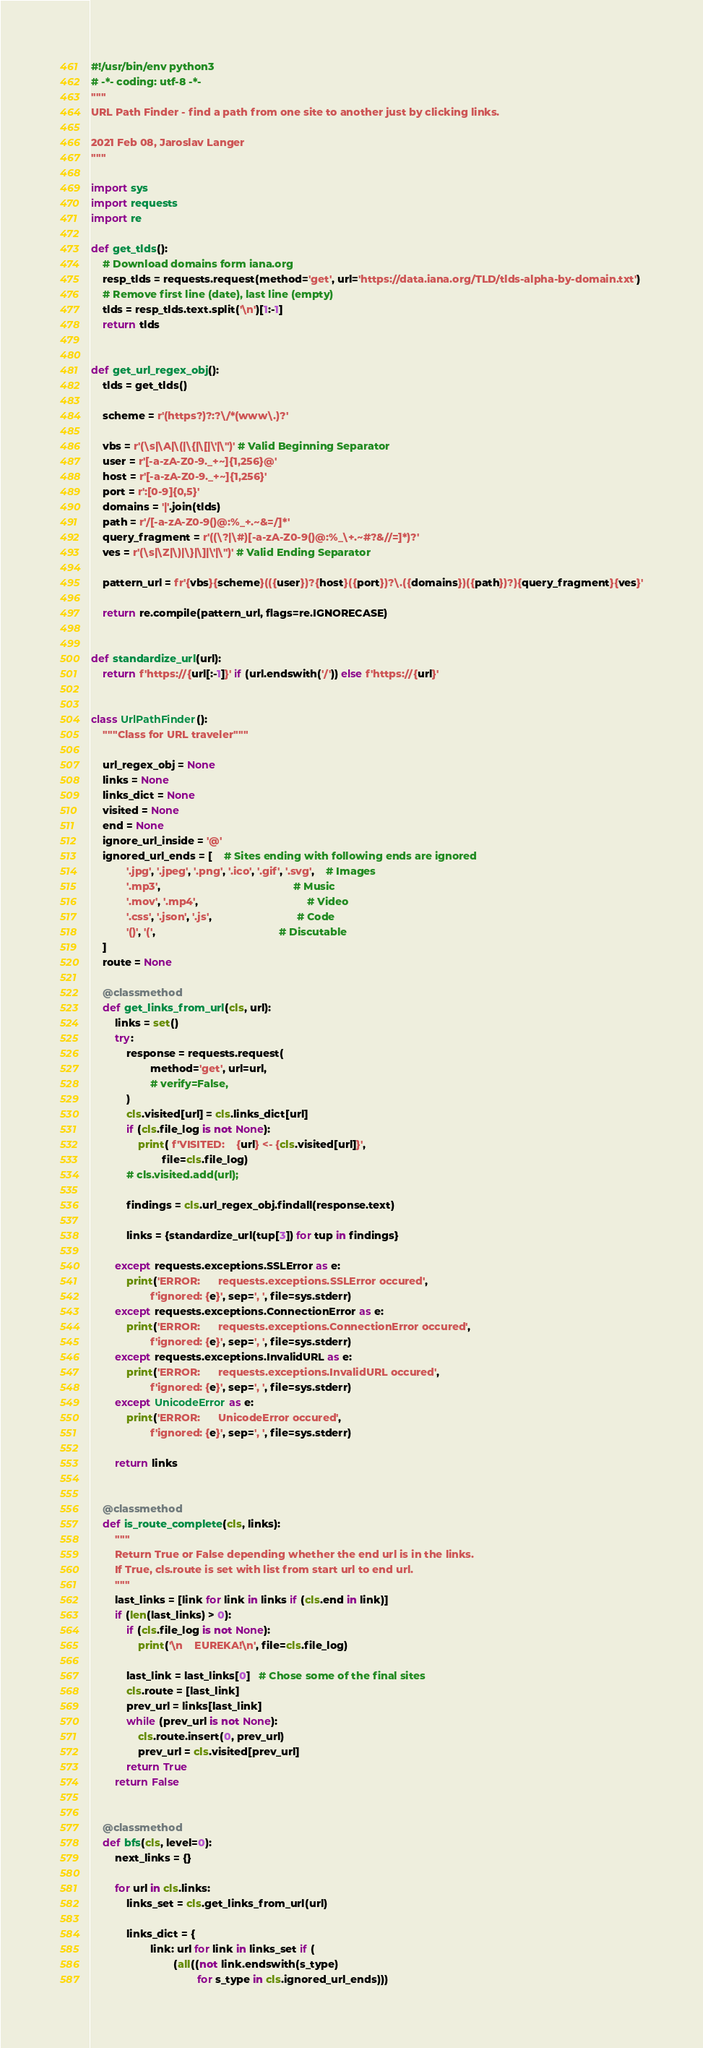<code> <loc_0><loc_0><loc_500><loc_500><_Python_>#!/usr/bin/env python3
# -*- coding: utf-8 -*-
"""
URL Path Finder - find a path from one site to another just by clicking links.

2021 Feb 08, Jaroslav Langer
"""

import sys
import requests
import re

def get_tlds():
    # Download domains form iana.org
    resp_tlds = requests.request(method='get', url='https://data.iana.org/TLD/tlds-alpha-by-domain.txt')
    # Remove first line (date), last line (empty)
    tlds = resp_tlds.text.split('\n')[1:-1]
    return tlds


def get_url_regex_obj():
    tlds = get_tlds()

    scheme = r'(https?)?:?\/*(www\.)?'

    vbs = r'(\s|\A|\(|\{|\[|\'|\")' # Valid Beginning Separator
    user = r'[-a-zA-Z0-9._+~]{1,256}@'
    host = r'[-a-zA-Z0-9._+~]{1,256}'
    port = r':[0-9]{0,5}'
    domains = '|'.join(tlds)
    path = r'/[-a-zA-Z0-9()@:%_+.~&=/]*'
    query_fragment = r'((\?|\#)[-a-zA-Z0-9()@:%_\+.~#?&//=]*)?'
    ves = r'(\s|\Z|\)|\}|\]|\'|\")' # Valid Ending Separator

    pattern_url = fr'{vbs}{scheme}(({user})?{host}({port})?\.({domains})({path})?){query_fragment}{ves}'

    return re.compile(pattern_url, flags=re.IGNORECASE)


def standardize_url(url):
    return f'https://{url[:-1]}' if (url.endswith('/')) else f'https://{url}'


class UrlPathFinder():
    """Class for URL traveler"""

    url_regex_obj = None
    links = None
    links_dict = None
    visited = None
    end = None
    ignore_url_inside = '@'
    ignored_url_ends = [    # Sites ending with following ends are ignored
            '.jpg', '.jpeg', '.png', '.ico', '.gif', '.svg',    # Images
            '.mp3',                                             # Music
            '.mov', '.mp4',                                     # Video
            '.css', '.json', '.js',                             # Code
            '()', '(',                                          # Discutable
    ]
    route = None

    @classmethod
    def get_links_from_url(cls, url):
        links = set()
        try:
            response = requests.request(
                    method='get', url=url,
                    # verify=False,
            )
            cls.visited[url] = cls.links_dict[url]
            if (cls.file_log is not None):
                print( f'VISITED:    {url} <- {cls.visited[url]}',
                        file=cls.file_log)
            # cls.visited.add(url);

            findings = cls.url_regex_obj.findall(response.text)

            links = {standardize_url(tup[3]) for tup in findings}

        except requests.exceptions.SSLError as e:
            print('ERROR:      requests.exceptions.SSLError occured',
                    f'ignored: {e}', sep=', ', file=sys.stderr)
        except requests.exceptions.ConnectionError as e:
            print('ERROR:      requests.exceptions.ConnectionError occured',
                    f'ignored: {e}', sep=', ', file=sys.stderr)
        except requests.exceptions.InvalidURL as e:
            print('ERROR:      requests.exceptions.InvalidURL occured',
                    f'ignored: {e}', sep=', ', file=sys.stderr)
        except UnicodeError as e:
            print('ERROR:      UnicodeError occured',
                    f'ignored: {e}', sep=', ', file=sys.stderr)

        return links


    @classmethod
    def is_route_complete(cls, links):
        """
        Return True or False depending whether the end url is in the links.
        If True, cls.route is set with list from start url to end url.
        """
        last_links = [link for link in links if (cls.end in link)]
        if (len(last_links) > 0):
            if (cls.file_log is not None):
                print('\n    EUREKA!\n', file=cls.file_log)

            last_link = last_links[0]   # Chose some of the final sites
            cls.route = [last_link]
            prev_url = links[last_link]
            while (prev_url is not None):
                cls.route.insert(0, prev_url)
                prev_url = cls.visited[prev_url]
            return True
        return False


    @classmethod
    def bfs(cls, level=0):
        next_links = {}

        for url in cls.links:
            links_set = cls.get_links_from_url(url)

            links_dict = {
                    link: url for link in links_set if (
                            (all((not link.endswith(s_type)
                                    for s_type in cls.ignored_url_ends)))</code> 